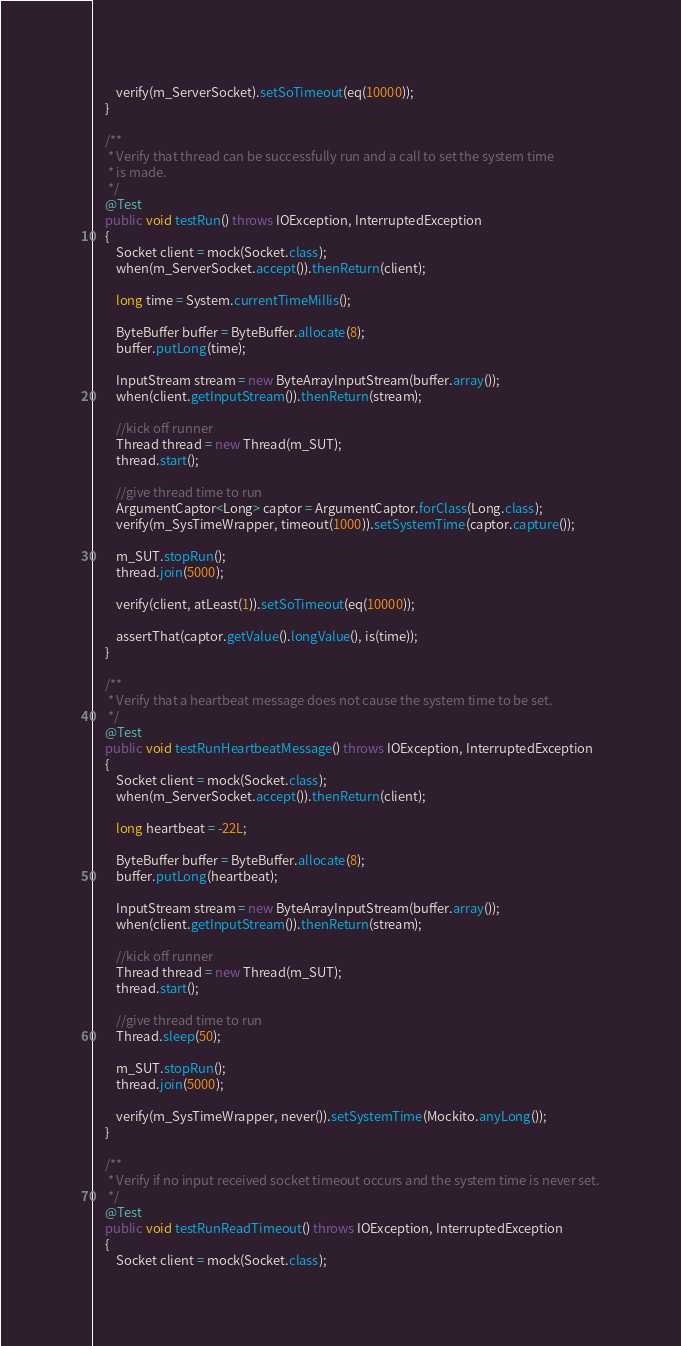Convert code to text. <code><loc_0><loc_0><loc_500><loc_500><_Java_>        verify(m_ServerSocket).setSoTimeout(eq(10000));
    }
    
    /**
     * Verify that thread can be successfully run and a call to set the system time 
     * is made.
     */
    @Test
    public void testRun() throws IOException, InterruptedException
    {
        Socket client = mock(Socket.class);
        when(m_ServerSocket.accept()).thenReturn(client);
        
        long time = System.currentTimeMillis();
        
        ByteBuffer buffer = ByteBuffer.allocate(8);
        buffer.putLong(time);
        
        InputStream stream = new ByteArrayInputStream(buffer.array());
        when(client.getInputStream()).thenReturn(stream);
        
        //kick off runner
        Thread thread = new Thread(m_SUT);
        thread.start();
        
        //give thread time to run
        ArgumentCaptor<Long> captor = ArgumentCaptor.forClass(Long.class);
        verify(m_SysTimeWrapper, timeout(1000)).setSystemTime(captor.capture());
        
        m_SUT.stopRun();
        thread.join(5000);
        
        verify(client, atLeast(1)).setSoTimeout(eq(10000));
        
        assertThat(captor.getValue().longValue(), is(time));
    }
    
    /**
     * Verify that a heartbeat message does not cause the system time to be set.
     */
    @Test
    public void testRunHeartbeatMessage() throws IOException, InterruptedException
    {
        Socket client = mock(Socket.class);
        when(m_ServerSocket.accept()).thenReturn(client);
        
        long heartbeat = -22L;
        
        ByteBuffer buffer = ByteBuffer.allocate(8);
        buffer.putLong(heartbeat);
        
        InputStream stream = new ByteArrayInputStream(buffer.array());
        when(client.getInputStream()).thenReturn(stream);
        
        //kick off runner
        Thread thread = new Thread(m_SUT);
        thread.start();
        
        //give thread time to run
        Thread.sleep(50);
        
        m_SUT.stopRun();
        thread.join(5000);
        
        verify(m_SysTimeWrapper, never()).setSystemTime(Mockito.anyLong());
    }
    
    /**
     * Verify if no input received socket timeout occurs and the system time is never set.
     */
    @Test
    public void testRunReadTimeout() throws IOException, InterruptedException
    {
        Socket client = mock(Socket.class);</code> 